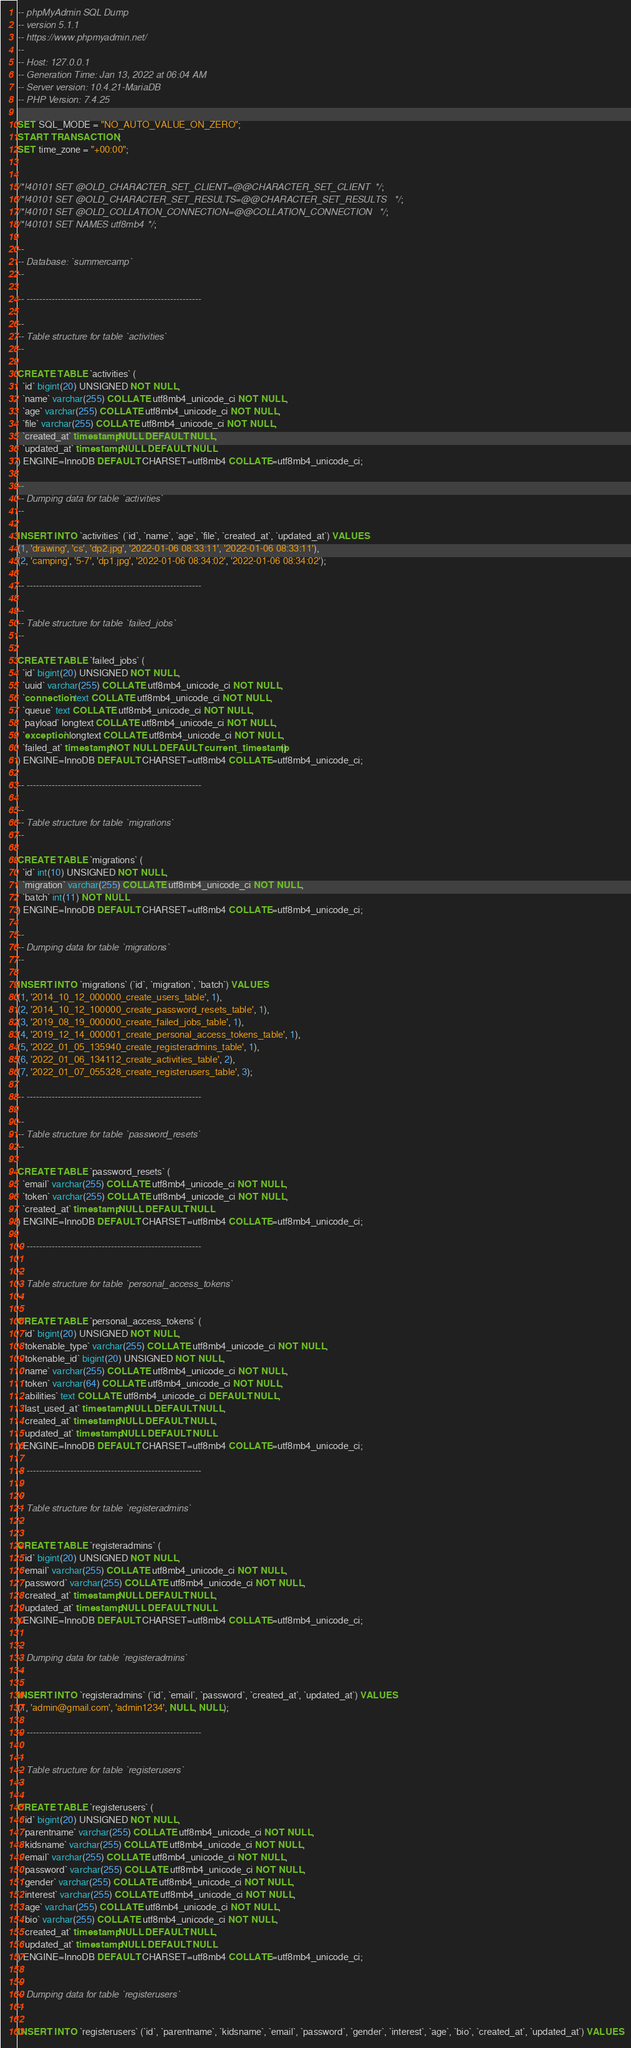<code> <loc_0><loc_0><loc_500><loc_500><_SQL_>-- phpMyAdmin SQL Dump
-- version 5.1.1
-- https://www.phpmyadmin.net/
--
-- Host: 127.0.0.1
-- Generation Time: Jan 13, 2022 at 06:04 AM
-- Server version: 10.4.21-MariaDB
-- PHP Version: 7.4.25

SET SQL_MODE = "NO_AUTO_VALUE_ON_ZERO";
START TRANSACTION;
SET time_zone = "+00:00";


/*!40101 SET @OLD_CHARACTER_SET_CLIENT=@@CHARACTER_SET_CLIENT */;
/*!40101 SET @OLD_CHARACTER_SET_RESULTS=@@CHARACTER_SET_RESULTS */;
/*!40101 SET @OLD_COLLATION_CONNECTION=@@COLLATION_CONNECTION */;
/*!40101 SET NAMES utf8mb4 */;

--
-- Database: `summercamp`
--

-- --------------------------------------------------------

--
-- Table structure for table `activities`
--

CREATE TABLE `activities` (
  `id` bigint(20) UNSIGNED NOT NULL,
  `name` varchar(255) COLLATE utf8mb4_unicode_ci NOT NULL,
  `age` varchar(255) COLLATE utf8mb4_unicode_ci NOT NULL,
  `file` varchar(255) COLLATE utf8mb4_unicode_ci NOT NULL,
  `created_at` timestamp NULL DEFAULT NULL,
  `updated_at` timestamp NULL DEFAULT NULL
) ENGINE=InnoDB DEFAULT CHARSET=utf8mb4 COLLATE=utf8mb4_unicode_ci;

--
-- Dumping data for table `activities`
--

INSERT INTO `activities` (`id`, `name`, `age`, `file`, `created_at`, `updated_at`) VALUES
(1, 'drawing', 'cs', 'dp2.jpg', '2022-01-06 08:33:11', '2022-01-06 08:33:11'),
(2, 'camping', '5-7', 'dp1.jpg', '2022-01-06 08:34:02', '2022-01-06 08:34:02');

-- --------------------------------------------------------

--
-- Table structure for table `failed_jobs`
--

CREATE TABLE `failed_jobs` (
  `id` bigint(20) UNSIGNED NOT NULL,
  `uuid` varchar(255) COLLATE utf8mb4_unicode_ci NOT NULL,
  `connection` text COLLATE utf8mb4_unicode_ci NOT NULL,
  `queue` text COLLATE utf8mb4_unicode_ci NOT NULL,
  `payload` longtext COLLATE utf8mb4_unicode_ci NOT NULL,
  `exception` longtext COLLATE utf8mb4_unicode_ci NOT NULL,
  `failed_at` timestamp NOT NULL DEFAULT current_timestamp()
) ENGINE=InnoDB DEFAULT CHARSET=utf8mb4 COLLATE=utf8mb4_unicode_ci;

-- --------------------------------------------------------

--
-- Table structure for table `migrations`
--

CREATE TABLE `migrations` (
  `id` int(10) UNSIGNED NOT NULL,
  `migration` varchar(255) COLLATE utf8mb4_unicode_ci NOT NULL,
  `batch` int(11) NOT NULL
) ENGINE=InnoDB DEFAULT CHARSET=utf8mb4 COLLATE=utf8mb4_unicode_ci;

--
-- Dumping data for table `migrations`
--

INSERT INTO `migrations` (`id`, `migration`, `batch`) VALUES
(1, '2014_10_12_000000_create_users_table', 1),
(2, '2014_10_12_100000_create_password_resets_table', 1),
(3, '2019_08_19_000000_create_failed_jobs_table', 1),
(4, '2019_12_14_000001_create_personal_access_tokens_table', 1),
(5, '2022_01_05_135940_create_registeradmins_table', 1),
(6, '2022_01_06_134112_create_activities_table', 2),
(7, '2022_01_07_055328_create_registerusers_table', 3);

-- --------------------------------------------------------

--
-- Table structure for table `password_resets`
--

CREATE TABLE `password_resets` (
  `email` varchar(255) COLLATE utf8mb4_unicode_ci NOT NULL,
  `token` varchar(255) COLLATE utf8mb4_unicode_ci NOT NULL,
  `created_at` timestamp NULL DEFAULT NULL
) ENGINE=InnoDB DEFAULT CHARSET=utf8mb4 COLLATE=utf8mb4_unicode_ci;

-- --------------------------------------------------------

--
-- Table structure for table `personal_access_tokens`
--

CREATE TABLE `personal_access_tokens` (
  `id` bigint(20) UNSIGNED NOT NULL,
  `tokenable_type` varchar(255) COLLATE utf8mb4_unicode_ci NOT NULL,
  `tokenable_id` bigint(20) UNSIGNED NOT NULL,
  `name` varchar(255) COLLATE utf8mb4_unicode_ci NOT NULL,
  `token` varchar(64) COLLATE utf8mb4_unicode_ci NOT NULL,
  `abilities` text COLLATE utf8mb4_unicode_ci DEFAULT NULL,
  `last_used_at` timestamp NULL DEFAULT NULL,
  `created_at` timestamp NULL DEFAULT NULL,
  `updated_at` timestamp NULL DEFAULT NULL
) ENGINE=InnoDB DEFAULT CHARSET=utf8mb4 COLLATE=utf8mb4_unicode_ci;

-- --------------------------------------------------------

--
-- Table structure for table `registeradmins`
--

CREATE TABLE `registeradmins` (
  `id` bigint(20) UNSIGNED NOT NULL,
  `email` varchar(255) COLLATE utf8mb4_unicode_ci NOT NULL,
  `password` varchar(255) COLLATE utf8mb4_unicode_ci NOT NULL,
  `created_at` timestamp NULL DEFAULT NULL,
  `updated_at` timestamp NULL DEFAULT NULL
) ENGINE=InnoDB DEFAULT CHARSET=utf8mb4 COLLATE=utf8mb4_unicode_ci;

--
-- Dumping data for table `registeradmins`
--

INSERT INTO `registeradmins` (`id`, `email`, `password`, `created_at`, `updated_at`) VALUES
(1, 'admin@gmail.com', 'admin1234', NULL, NULL);

-- --------------------------------------------------------

--
-- Table structure for table `registerusers`
--

CREATE TABLE `registerusers` (
  `id` bigint(20) UNSIGNED NOT NULL,
  `parentname` varchar(255) COLLATE utf8mb4_unicode_ci NOT NULL,
  `kidsname` varchar(255) COLLATE utf8mb4_unicode_ci NOT NULL,
  `email` varchar(255) COLLATE utf8mb4_unicode_ci NOT NULL,
  `password` varchar(255) COLLATE utf8mb4_unicode_ci NOT NULL,
  `gender` varchar(255) COLLATE utf8mb4_unicode_ci NOT NULL,
  `interest` varchar(255) COLLATE utf8mb4_unicode_ci NOT NULL,
  `age` varchar(255) COLLATE utf8mb4_unicode_ci NOT NULL,
  `bio` varchar(255) COLLATE utf8mb4_unicode_ci NOT NULL,
  `created_at` timestamp NULL DEFAULT NULL,
  `updated_at` timestamp NULL DEFAULT NULL
) ENGINE=InnoDB DEFAULT CHARSET=utf8mb4 COLLATE=utf8mb4_unicode_ci;

--
-- Dumping data for table `registerusers`
--

INSERT INTO `registerusers` (`id`, `parentname`, `kidsname`, `email`, `password`, `gender`, `interest`, `age`, `bio`, `created_at`, `updated_at`) VALUES</code> 